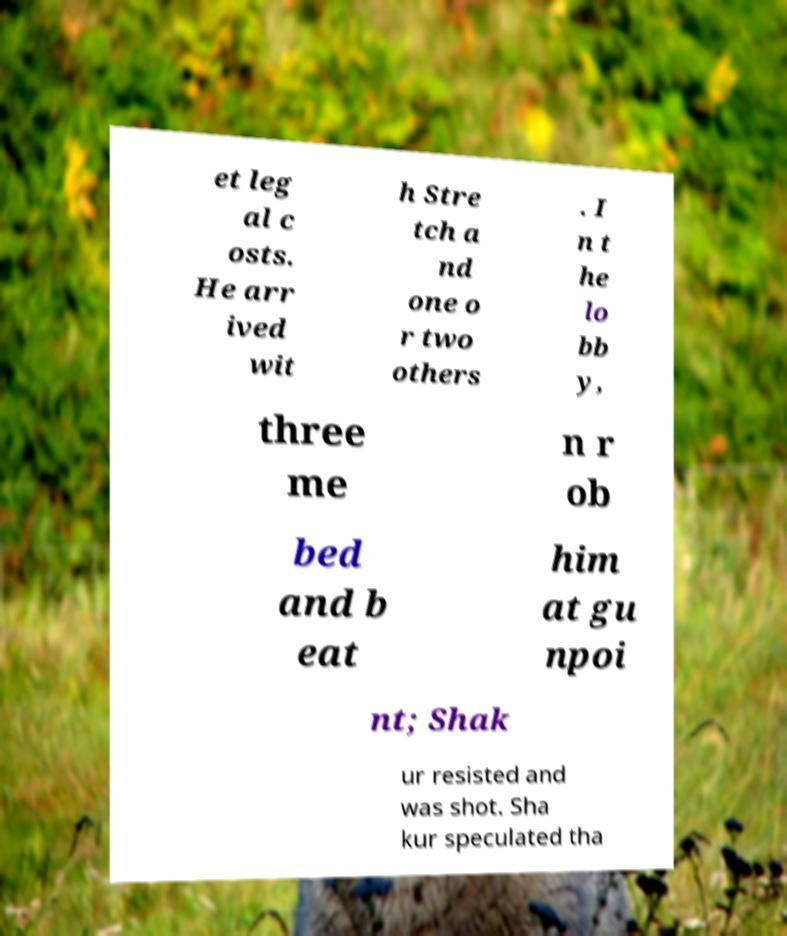There's text embedded in this image that I need extracted. Can you transcribe it verbatim? et leg al c osts. He arr ived wit h Stre tch a nd one o r two others . I n t he lo bb y, three me n r ob bed and b eat him at gu npoi nt; Shak ur resisted and was shot. Sha kur speculated tha 